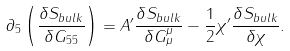<formula> <loc_0><loc_0><loc_500><loc_500>\partial _ { 5 } \left ( \frac { \delta S _ { b u l k } } { \delta G _ { 5 5 } } \right ) = A ^ { \prime } \frac { \delta S _ { b u l k } } { \delta G ^ { \mu } _ { \mu } } - \frac { 1 } { 2 } \chi ^ { \prime } \frac { \delta S _ { b u l k } } { \delta \chi } .</formula> 